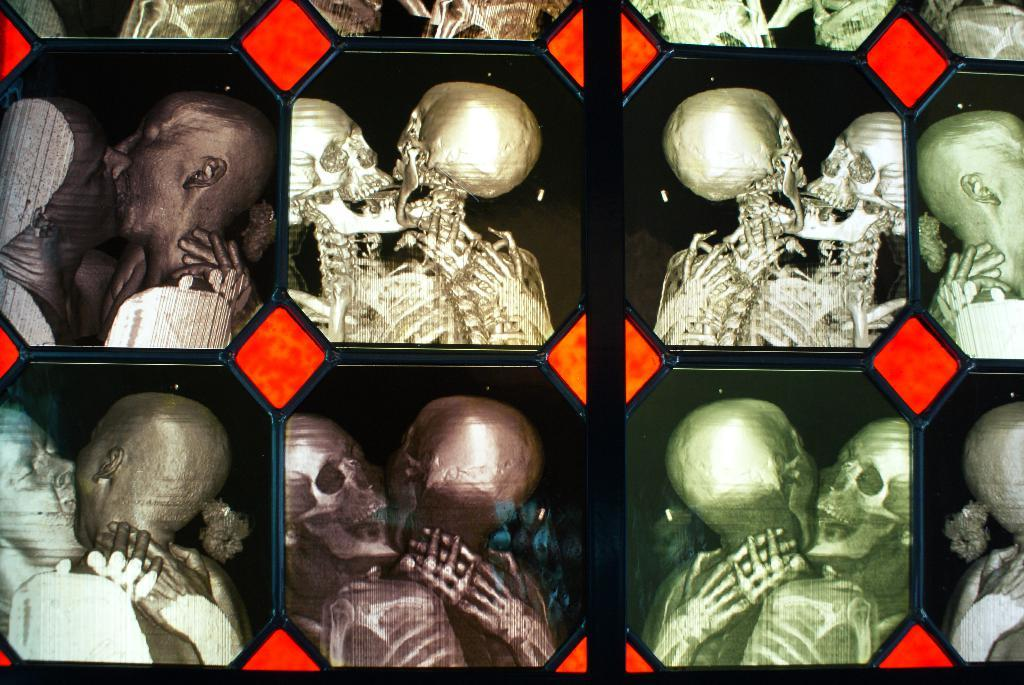What objects are present in the image? There are photo frames in the image. What is depicted in the photo frames? The photo frames contain images of skeletons hugging and kissing. What is happening on the left side of the image? There are persons hugging and kissing on the left side of the image. Can you tell me how many monkeys are sitting in the tub in the image? There are no monkeys or tubs present in the image. 